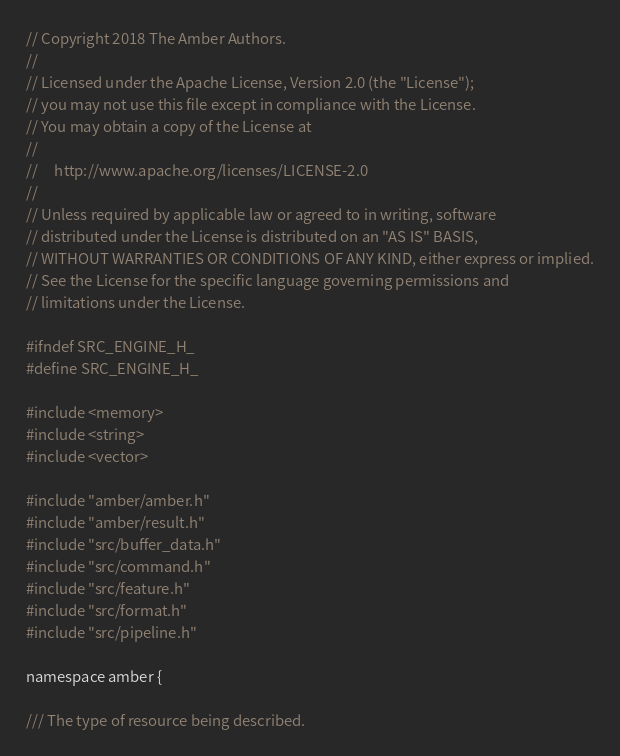Convert code to text. <code><loc_0><loc_0><loc_500><loc_500><_C_>// Copyright 2018 The Amber Authors.
//
// Licensed under the Apache License, Version 2.0 (the "License");
// you may not use this file except in compliance with the License.
// You may obtain a copy of the License at
//
//     http://www.apache.org/licenses/LICENSE-2.0
//
// Unless required by applicable law or agreed to in writing, software
// distributed under the License is distributed on an "AS IS" BASIS,
// WITHOUT WARRANTIES OR CONDITIONS OF ANY KIND, either express or implied.
// See the License for the specific language governing permissions and
// limitations under the License.

#ifndef SRC_ENGINE_H_
#define SRC_ENGINE_H_

#include <memory>
#include <string>
#include <vector>

#include "amber/amber.h"
#include "amber/result.h"
#include "src/buffer_data.h"
#include "src/command.h"
#include "src/feature.h"
#include "src/format.h"
#include "src/pipeline.h"

namespace amber {

/// The type of resource being described.</code> 